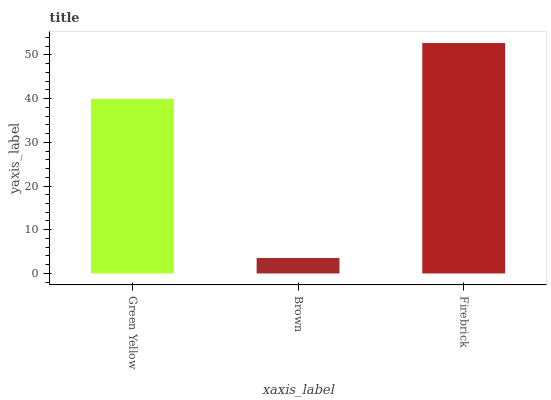Is Brown the minimum?
Answer yes or no. Yes. Is Firebrick the maximum?
Answer yes or no. Yes. Is Firebrick the minimum?
Answer yes or no. No. Is Brown the maximum?
Answer yes or no. No. Is Firebrick greater than Brown?
Answer yes or no. Yes. Is Brown less than Firebrick?
Answer yes or no. Yes. Is Brown greater than Firebrick?
Answer yes or no. No. Is Firebrick less than Brown?
Answer yes or no. No. Is Green Yellow the high median?
Answer yes or no. Yes. Is Green Yellow the low median?
Answer yes or no. Yes. Is Brown the high median?
Answer yes or no. No. Is Firebrick the low median?
Answer yes or no. No. 